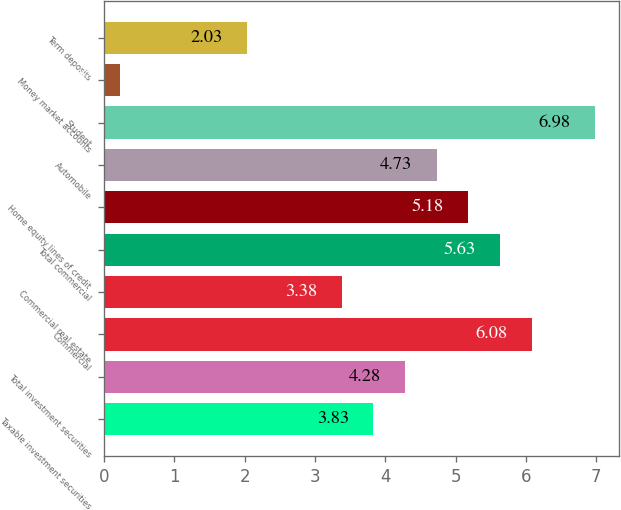<chart> <loc_0><loc_0><loc_500><loc_500><bar_chart><fcel>Taxable investment securities<fcel>Total investment securities<fcel>Commercial<fcel>Commercial real estate<fcel>Total commercial<fcel>Home equity lines of credit<fcel>Automobile<fcel>Student<fcel>Money market accounts<fcel>Term deposits<nl><fcel>3.83<fcel>4.28<fcel>6.08<fcel>3.38<fcel>5.63<fcel>5.18<fcel>4.73<fcel>6.98<fcel>0.23<fcel>2.03<nl></chart> 